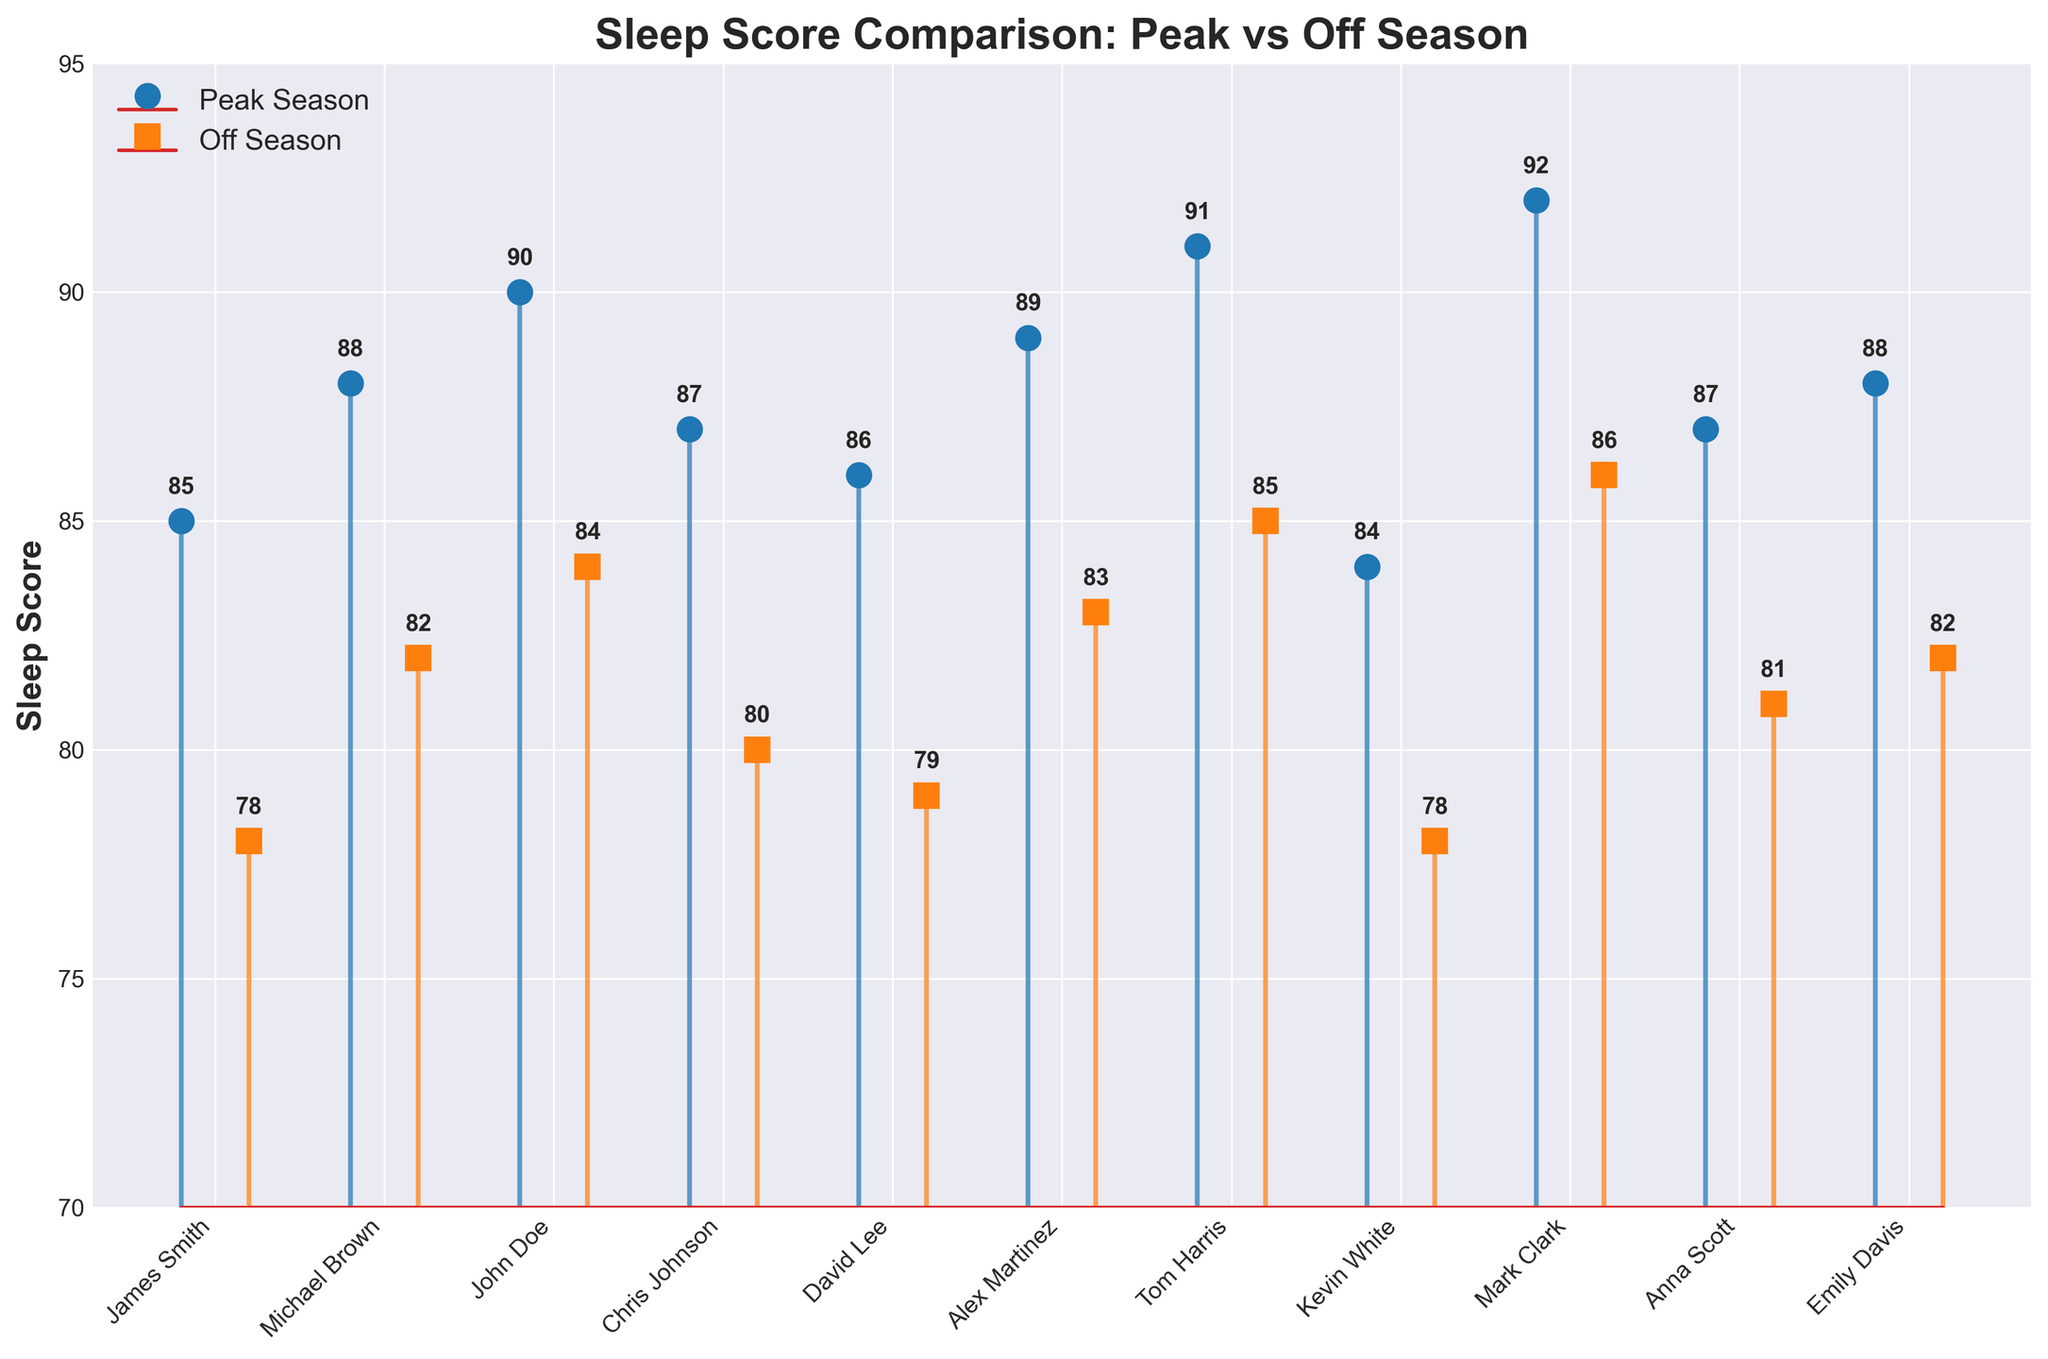What is the title of the figure? The title of the figure is usually placed at the top and provides a summary of what the chart is about. In this case, the title is written in bold and large-sized font.
Answer: Sleep Score Comparison: Peak vs Off Season Which season generally has higher sleep scores? By observing the plotted points, peak season sleep scores are consistently above or equal to off season scores across all athletes.
Answer: Peak season What is the sleep score difference for John Doe between peak and off season? John Doe's sleep score in peak season is 90, and in off season it is 84. The difference is calculated by subtracting the off season score from the peak season score (90 - 84).
Answer: 6 How many athletes have a peak season sleep score above 88? By scanning the peak season sleep score markers, athletes with scores above 88 are John Doe, Alex Martinez, Tom Harris, Mark Clark. Therefore, there are 4 athletes.
Answer: 4 What is the range of sleep scores during the off season? The lowest off season sleep score is 78 and the highest off season sleep score is 86. The range is calculated by subtracting the lowest score from the highest score (86 - 78).
Answer: 8 What is the average sleep score in the peak season? To find the average, sum all peak season sleep scores (85 + 88 + 90 + 87 + 86 + 89 + 91 + 84 + 92 + 87 + 88) which is 957, and then divide by the number of athletes, which is 11 (957 / 11).
Answer: 87 Which athlete has the largest sleep score difference between peak and off season? By calculating the difference between peak and off season sleep scores for each athlete: James Smith (7), Michael Brown (6), John Doe (6), Chris Johnson (7), David Lee (7), Alex Martinez (6), Tom Harris (6), Kevin White (6), Mark Clark (6), Anna Scott (6), Emily Davis (6). The largest difference is shared by James Smith, Chris Johnson, and David Lee, all with a difference of 7.
Answer: James Smith, Chris Johnson, David Lee If Tom Harris improved his off season sleep score to match his peak season score, what would be the new average off season sleep score? First, calculate the current total off season sleep score by summing all off season scores: (78 + 82 + 84 + 80 + 79 + 83 + 85 + 78 + 86 + 81 + 82) which is 918. Tom Harris' current off season score is 85, and his peak season score is 91, so the difference is 91 - 85 = 6. Adding this difference to the total: (918 + 6), gives 924. To find the new average: 924 / 11.
Answer: 84 Which season has higher variability in sleep scores? To determine variability, compare the range and spread of data points for each season. The peak season scores range from 84 to 92, while the off season scores range from 78 to 86. The off season scores show a greater range (86 - 78 = 8) compared to peak season (92 - 84 = 8).
Answer: Off season 